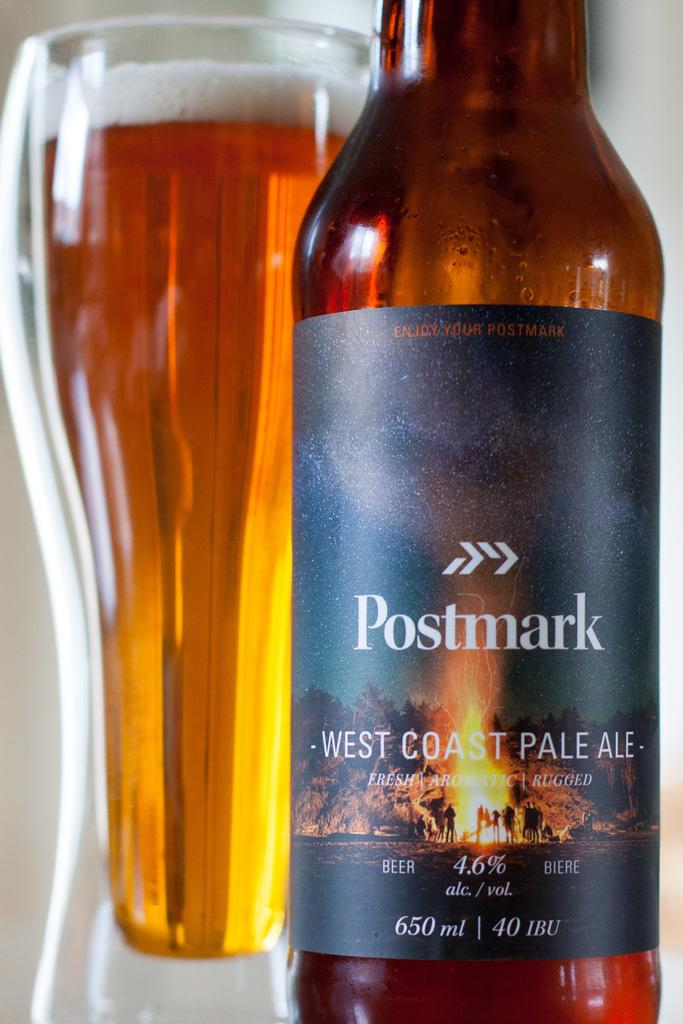<image>
Relay a brief, clear account of the picture shown. A bottle of Postmark west coast pale ale next to a drinking glass full of beer. 